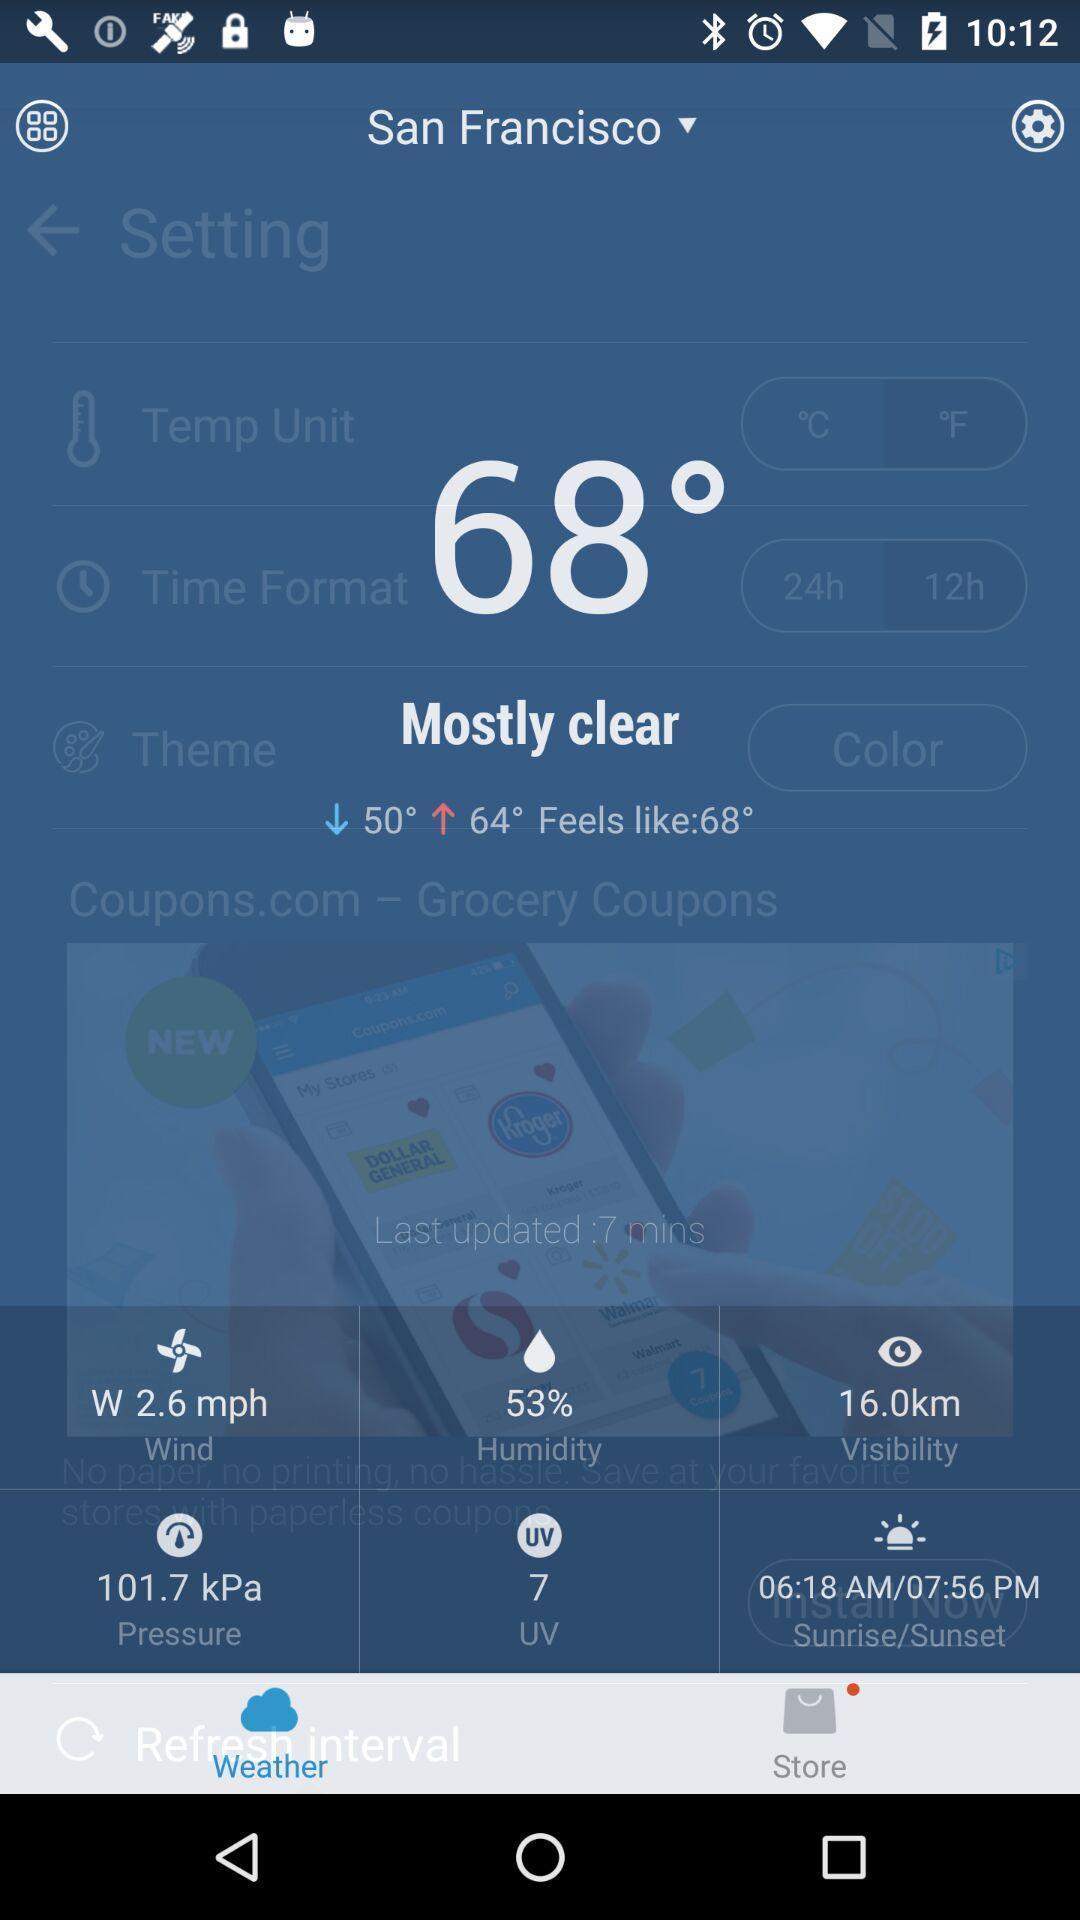Summarize the main components in this picture. Pop-up shows details in weather application. 